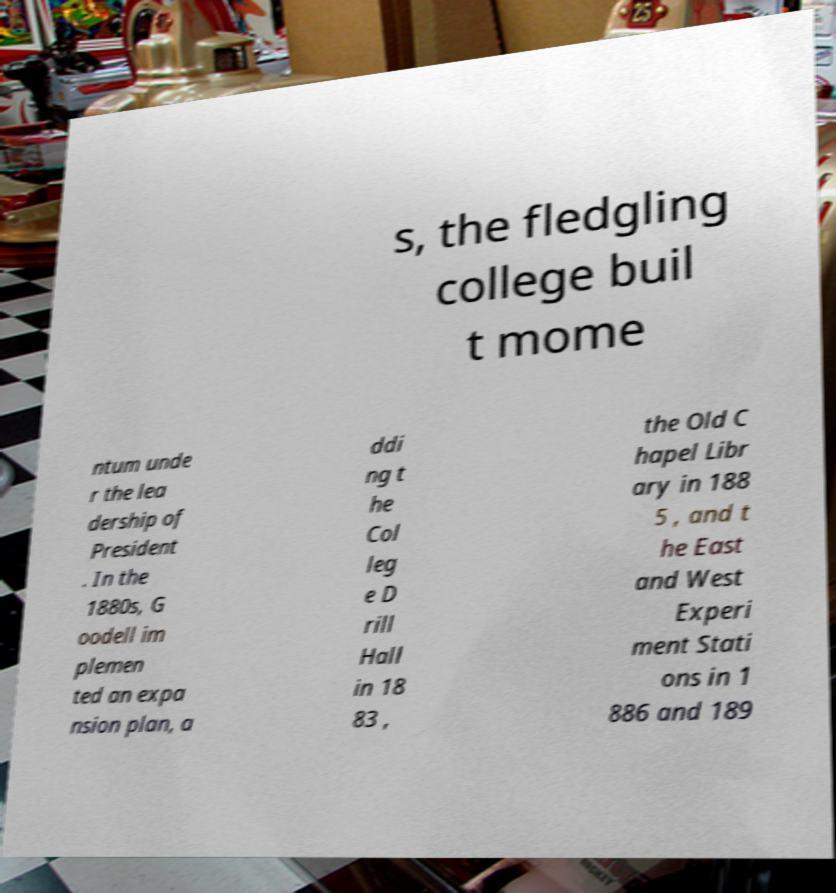Please read and relay the text visible in this image. What does it say? s, the fledgling college buil t mome ntum unde r the lea dership of President . In the 1880s, G oodell im plemen ted an expa nsion plan, a ddi ng t he Col leg e D rill Hall in 18 83 , the Old C hapel Libr ary in 188 5 , and t he East and West Experi ment Stati ons in 1 886 and 189 